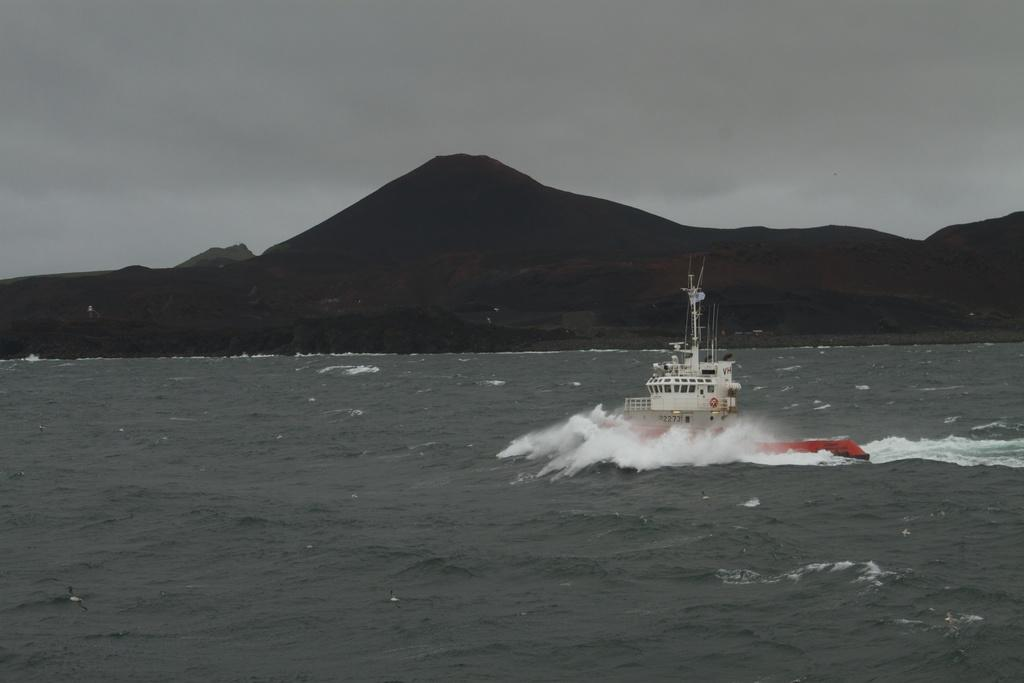What is the main subject of the image? There is a ship in the image. Where is the ship located in the image? The ship is on the right side of the image. What is the ship's location in relation to the water? The ship is on the water. What can be seen in the background of the image? There are mountains in the background of the image. How many children are playing on the train in the image? There is no train or children present in the image; it features a ship on the water with mountains in the background. 